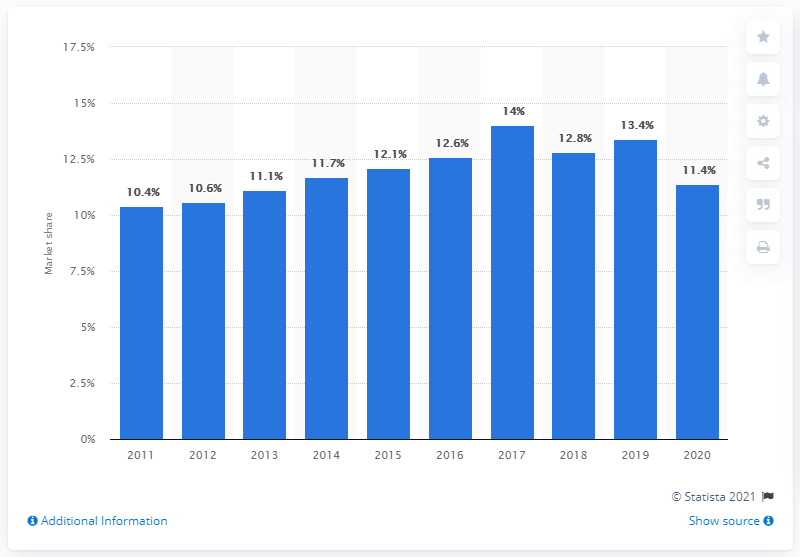Identify some key points in this picture. In 2011, the smallest mortgage market share for Nationwide was 10.4%. 